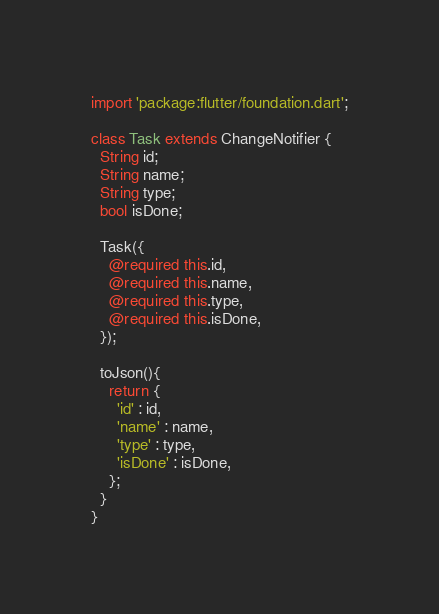Convert code to text. <code><loc_0><loc_0><loc_500><loc_500><_Dart_>import 'package:flutter/foundation.dart';

class Task extends ChangeNotifier {
  String id;
  String name;
  String type;
  bool isDone;

  Task({
    @required this.id,
    @required this.name,
    @required this.type,
    @required this.isDone,
  });

  toJson(){
    return {
      'id' : id,
      'name' : name,
      'type' : type,
      'isDone' : isDone,
    };
  }
}</code> 